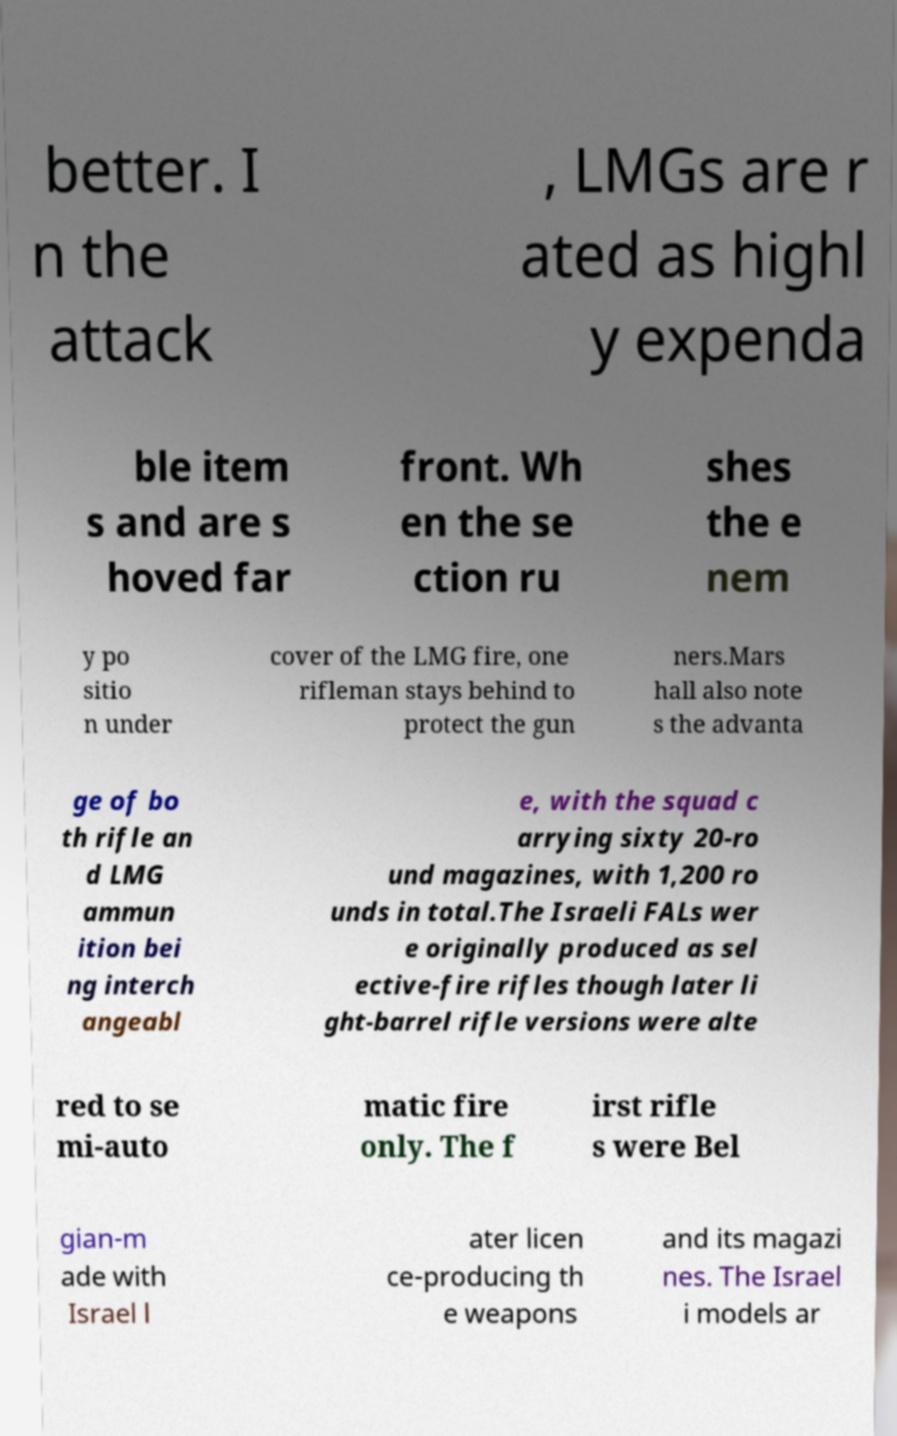Please identify and transcribe the text found in this image. better. I n the attack , LMGs are r ated as highl y expenda ble item s and are s hoved far front. Wh en the se ction ru shes the e nem y po sitio n under cover of the LMG fire, one rifleman stays behind to protect the gun ners.Mars hall also note s the advanta ge of bo th rifle an d LMG ammun ition bei ng interch angeabl e, with the squad c arrying sixty 20-ro und magazines, with 1,200 ro unds in total.The Israeli FALs wer e originally produced as sel ective-fire rifles though later li ght-barrel rifle versions were alte red to se mi-auto matic fire only. The f irst rifle s were Bel gian-m ade with Israel l ater licen ce-producing th e weapons and its magazi nes. The Israel i models ar 